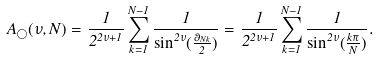<formula> <loc_0><loc_0><loc_500><loc_500>A _ { \bigcirc } ( \nu , N ) = \frac { 1 } { 2 ^ { 2 \nu + 1 } } \sum _ { k = 1 } ^ { N - 1 } \frac { 1 } { \sin ^ { 2 \nu } ( \frac { \theta _ { N k } } { 2 } ) } = \frac { 1 } { 2 ^ { 2 \nu + 1 } } \sum _ { k = 1 } ^ { N - 1 } \frac { 1 } { \sin ^ { 2 \nu } ( \frac { k \pi } { N } ) } .</formula> 